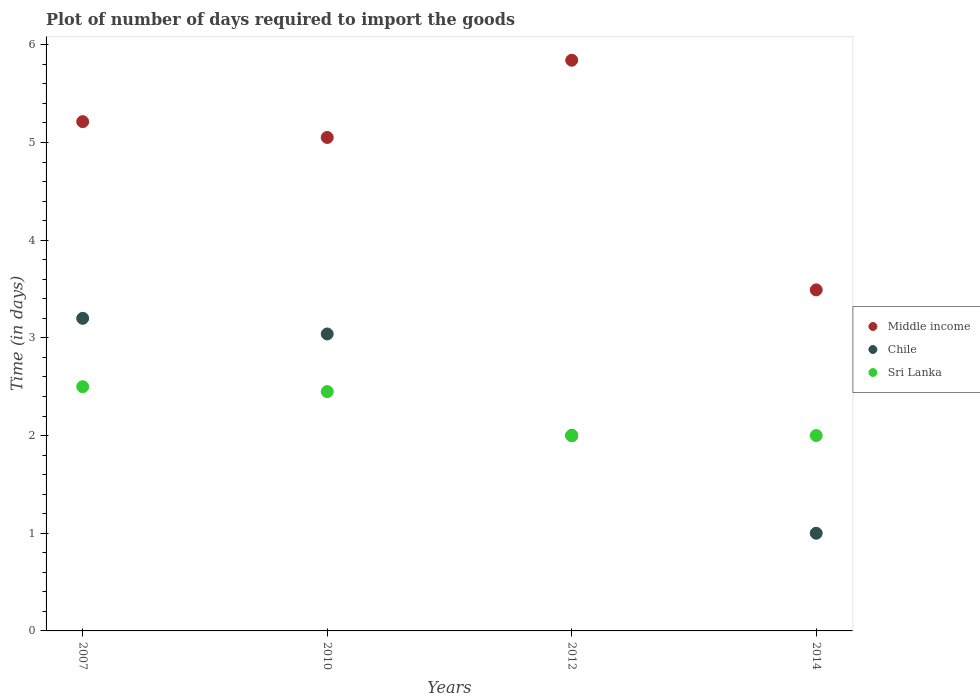How many different coloured dotlines are there?
Your answer should be compact. 3. Is the number of dotlines equal to the number of legend labels?
Keep it short and to the point. Yes. What is the time required to import goods in Sri Lanka in 2007?
Your response must be concise. 2.5. Across all years, what is the maximum time required to import goods in Middle income?
Give a very brief answer. 5.84. In which year was the time required to import goods in Sri Lanka maximum?
Provide a short and direct response. 2007. In which year was the time required to import goods in Sri Lanka minimum?
Offer a very short reply. 2012. What is the total time required to import goods in Sri Lanka in the graph?
Your response must be concise. 8.95. What is the difference between the time required to import goods in Middle income in 2010 and that in 2012?
Your answer should be compact. -0.79. What is the difference between the time required to import goods in Chile in 2014 and the time required to import goods in Sri Lanka in 2007?
Keep it short and to the point. -1.5. What is the average time required to import goods in Chile per year?
Offer a very short reply. 2.31. In the year 2010, what is the difference between the time required to import goods in Chile and time required to import goods in Sri Lanka?
Your answer should be compact. 0.59. What is the ratio of the time required to import goods in Sri Lanka in 2010 to that in 2012?
Provide a short and direct response. 1.23. What is the difference between the highest and the second highest time required to import goods in Middle income?
Your answer should be very brief. 0.63. What is the difference between the highest and the lowest time required to import goods in Sri Lanka?
Keep it short and to the point. 0.5. In how many years, is the time required to import goods in Middle income greater than the average time required to import goods in Middle income taken over all years?
Your answer should be very brief. 3. Is the sum of the time required to import goods in Chile in 2007 and 2012 greater than the maximum time required to import goods in Middle income across all years?
Your response must be concise. No. Does the time required to import goods in Chile monotonically increase over the years?
Your answer should be compact. No. Is the time required to import goods in Sri Lanka strictly less than the time required to import goods in Middle income over the years?
Your response must be concise. Yes. How many dotlines are there?
Provide a short and direct response. 3. What is the difference between two consecutive major ticks on the Y-axis?
Make the answer very short. 1. Are the values on the major ticks of Y-axis written in scientific E-notation?
Offer a very short reply. No. Does the graph contain any zero values?
Give a very brief answer. No. Does the graph contain grids?
Make the answer very short. No. Where does the legend appear in the graph?
Your answer should be very brief. Center right. How are the legend labels stacked?
Ensure brevity in your answer.  Vertical. What is the title of the graph?
Your answer should be very brief. Plot of number of days required to import the goods. What is the label or title of the X-axis?
Give a very brief answer. Years. What is the label or title of the Y-axis?
Your response must be concise. Time (in days). What is the Time (in days) in Middle income in 2007?
Keep it short and to the point. 5.21. What is the Time (in days) of Chile in 2007?
Your answer should be very brief. 3.2. What is the Time (in days) in Sri Lanka in 2007?
Your response must be concise. 2.5. What is the Time (in days) of Middle income in 2010?
Offer a very short reply. 5.05. What is the Time (in days) in Chile in 2010?
Provide a succinct answer. 3.04. What is the Time (in days) in Sri Lanka in 2010?
Provide a short and direct response. 2.45. What is the Time (in days) in Middle income in 2012?
Keep it short and to the point. 5.84. What is the Time (in days) of Middle income in 2014?
Ensure brevity in your answer.  3.49. What is the Time (in days) of Sri Lanka in 2014?
Your answer should be compact. 2. Across all years, what is the maximum Time (in days) in Middle income?
Make the answer very short. 5.84. Across all years, what is the minimum Time (in days) of Middle income?
Offer a terse response. 3.49. What is the total Time (in days) in Middle income in the graph?
Offer a very short reply. 19.6. What is the total Time (in days) in Chile in the graph?
Give a very brief answer. 9.24. What is the total Time (in days) of Sri Lanka in the graph?
Ensure brevity in your answer.  8.95. What is the difference between the Time (in days) in Middle income in 2007 and that in 2010?
Your answer should be compact. 0.16. What is the difference between the Time (in days) of Chile in 2007 and that in 2010?
Provide a short and direct response. 0.16. What is the difference between the Time (in days) of Middle income in 2007 and that in 2012?
Provide a short and direct response. -0.63. What is the difference between the Time (in days) in Chile in 2007 and that in 2012?
Give a very brief answer. 1.2. What is the difference between the Time (in days) of Middle income in 2007 and that in 2014?
Keep it short and to the point. 1.72. What is the difference between the Time (in days) in Sri Lanka in 2007 and that in 2014?
Give a very brief answer. 0.5. What is the difference between the Time (in days) in Middle income in 2010 and that in 2012?
Give a very brief answer. -0.79. What is the difference between the Time (in days) in Sri Lanka in 2010 and that in 2012?
Your answer should be very brief. 0.45. What is the difference between the Time (in days) of Middle income in 2010 and that in 2014?
Your answer should be compact. 1.56. What is the difference between the Time (in days) in Chile in 2010 and that in 2014?
Your answer should be very brief. 2.04. What is the difference between the Time (in days) in Sri Lanka in 2010 and that in 2014?
Keep it short and to the point. 0.45. What is the difference between the Time (in days) in Middle income in 2012 and that in 2014?
Ensure brevity in your answer.  2.35. What is the difference between the Time (in days) of Middle income in 2007 and the Time (in days) of Chile in 2010?
Your answer should be very brief. 2.17. What is the difference between the Time (in days) in Middle income in 2007 and the Time (in days) in Sri Lanka in 2010?
Offer a terse response. 2.76. What is the difference between the Time (in days) of Middle income in 2007 and the Time (in days) of Chile in 2012?
Your answer should be compact. 3.21. What is the difference between the Time (in days) of Middle income in 2007 and the Time (in days) of Sri Lanka in 2012?
Make the answer very short. 3.21. What is the difference between the Time (in days) of Chile in 2007 and the Time (in days) of Sri Lanka in 2012?
Offer a terse response. 1.2. What is the difference between the Time (in days) in Middle income in 2007 and the Time (in days) in Chile in 2014?
Offer a very short reply. 4.21. What is the difference between the Time (in days) of Middle income in 2007 and the Time (in days) of Sri Lanka in 2014?
Your response must be concise. 3.21. What is the difference between the Time (in days) in Chile in 2007 and the Time (in days) in Sri Lanka in 2014?
Give a very brief answer. 1.2. What is the difference between the Time (in days) in Middle income in 2010 and the Time (in days) in Chile in 2012?
Your answer should be compact. 3.05. What is the difference between the Time (in days) of Middle income in 2010 and the Time (in days) of Sri Lanka in 2012?
Offer a very short reply. 3.05. What is the difference between the Time (in days) in Chile in 2010 and the Time (in days) in Sri Lanka in 2012?
Provide a short and direct response. 1.04. What is the difference between the Time (in days) of Middle income in 2010 and the Time (in days) of Chile in 2014?
Provide a short and direct response. 4.05. What is the difference between the Time (in days) in Middle income in 2010 and the Time (in days) in Sri Lanka in 2014?
Offer a very short reply. 3.05. What is the difference between the Time (in days) in Chile in 2010 and the Time (in days) in Sri Lanka in 2014?
Offer a terse response. 1.04. What is the difference between the Time (in days) of Middle income in 2012 and the Time (in days) of Chile in 2014?
Your answer should be very brief. 4.84. What is the difference between the Time (in days) in Middle income in 2012 and the Time (in days) in Sri Lanka in 2014?
Your answer should be compact. 3.84. What is the average Time (in days) in Middle income per year?
Your response must be concise. 4.9. What is the average Time (in days) of Chile per year?
Give a very brief answer. 2.31. What is the average Time (in days) in Sri Lanka per year?
Give a very brief answer. 2.24. In the year 2007, what is the difference between the Time (in days) of Middle income and Time (in days) of Chile?
Keep it short and to the point. 2.01. In the year 2007, what is the difference between the Time (in days) of Middle income and Time (in days) of Sri Lanka?
Provide a succinct answer. 2.71. In the year 2007, what is the difference between the Time (in days) in Chile and Time (in days) in Sri Lanka?
Make the answer very short. 0.7. In the year 2010, what is the difference between the Time (in days) in Middle income and Time (in days) in Chile?
Provide a short and direct response. 2.01. In the year 2010, what is the difference between the Time (in days) of Middle income and Time (in days) of Sri Lanka?
Your response must be concise. 2.6. In the year 2010, what is the difference between the Time (in days) in Chile and Time (in days) in Sri Lanka?
Offer a terse response. 0.59. In the year 2012, what is the difference between the Time (in days) of Middle income and Time (in days) of Chile?
Provide a short and direct response. 3.84. In the year 2012, what is the difference between the Time (in days) of Middle income and Time (in days) of Sri Lanka?
Keep it short and to the point. 3.84. In the year 2012, what is the difference between the Time (in days) of Chile and Time (in days) of Sri Lanka?
Keep it short and to the point. 0. In the year 2014, what is the difference between the Time (in days) of Middle income and Time (in days) of Chile?
Provide a succinct answer. 2.49. In the year 2014, what is the difference between the Time (in days) of Middle income and Time (in days) of Sri Lanka?
Ensure brevity in your answer.  1.49. What is the ratio of the Time (in days) of Middle income in 2007 to that in 2010?
Your answer should be very brief. 1.03. What is the ratio of the Time (in days) of Chile in 2007 to that in 2010?
Keep it short and to the point. 1.05. What is the ratio of the Time (in days) in Sri Lanka in 2007 to that in 2010?
Your answer should be compact. 1.02. What is the ratio of the Time (in days) in Middle income in 2007 to that in 2012?
Provide a succinct answer. 0.89. What is the ratio of the Time (in days) in Sri Lanka in 2007 to that in 2012?
Your answer should be very brief. 1.25. What is the ratio of the Time (in days) in Middle income in 2007 to that in 2014?
Keep it short and to the point. 1.49. What is the ratio of the Time (in days) of Middle income in 2010 to that in 2012?
Offer a terse response. 0.86. What is the ratio of the Time (in days) of Chile in 2010 to that in 2012?
Provide a succinct answer. 1.52. What is the ratio of the Time (in days) in Sri Lanka in 2010 to that in 2012?
Make the answer very short. 1.23. What is the ratio of the Time (in days) in Middle income in 2010 to that in 2014?
Ensure brevity in your answer.  1.45. What is the ratio of the Time (in days) in Chile in 2010 to that in 2014?
Your answer should be very brief. 3.04. What is the ratio of the Time (in days) in Sri Lanka in 2010 to that in 2014?
Give a very brief answer. 1.23. What is the ratio of the Time (in days) of Middle income in 2012 to that in 2014?
Give a very brief answer. 1.67. What is the ratio of the Time (in days) of Chile in 2012 to that in 2014?
Offer a very short reply. 2. What is the ratio of the Time (in days) in Sri Lanka in 2012 to that in 2014?
Offer a terse response. 1. What is the difference between the highest and the second highest Time (in days) in Middle income?
Provide a short and direct response. 0.63. What is the difference between the highest and the second highest Time (in days) of Chile?
Your answer should be compact. 0.16. What is the difference between the highest and the lowest Time (in days) in Middle income?
Provide a succinct answer. 2.35. 